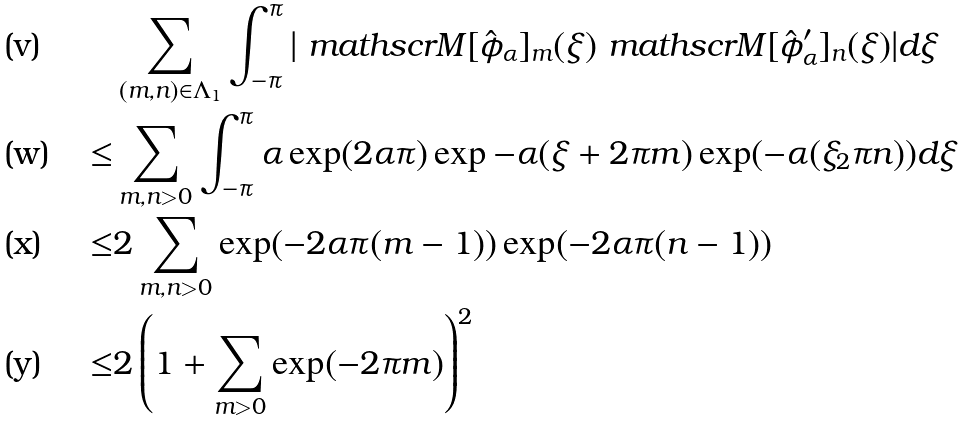Convert formula to latex. <formula><loc_0><loc_0><loc_500><loc_500>& \sum _ { ( m , n ) \in \Lambda _ { 1 } } \int _ { - \pi } ^ { \pi } | \ m a t h s c r { M } [ \hat { \phi } _ { \alpha } ] _ { m } ( \xi ) \ m a t h s c r { M } [ \hat { \phi } ^ { \prime } _ { \alpha } ] _ { n } ( \xi ) | d \xi \\ \leq & \sum _ { m , n > 0 } \int _ { - \pi } ^ { \pi } \alpha \exp ( 2 \alpha \pi ) \exp { - \alpha ( \xi + 2 \pi m ) } \exp ( - \alpha ( \xi _ { 2 } \pi n ) ) d \xi \\ \leq & 2 \sum _ { m , n > 0 } \exp ( - 2 \alpha \pi ( m - 1 ) ) \exp ( - 2 \alpha \pi ( n - 1 ) ) \\ \leq & 2 \left ( 1 + \sum _ { m > 0 } \exp ( - 2 \pi m ) \right ) ^ { 2 }</formula> 